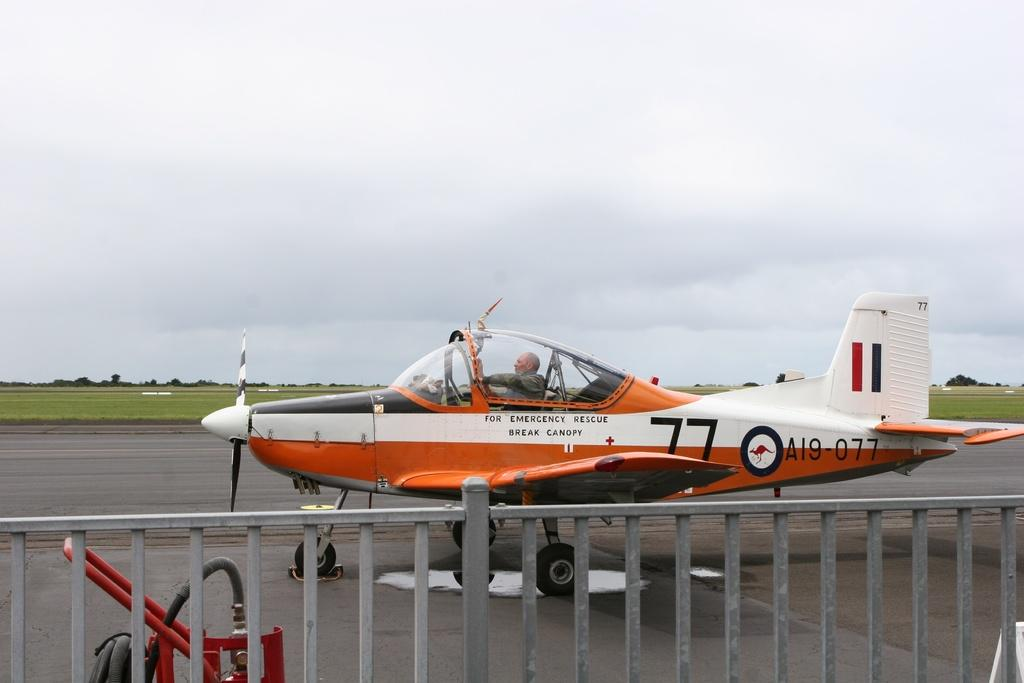<image>
Provide a brief description of the given image. A plane numbered A19-077 and for emergency rescue break canopy. 